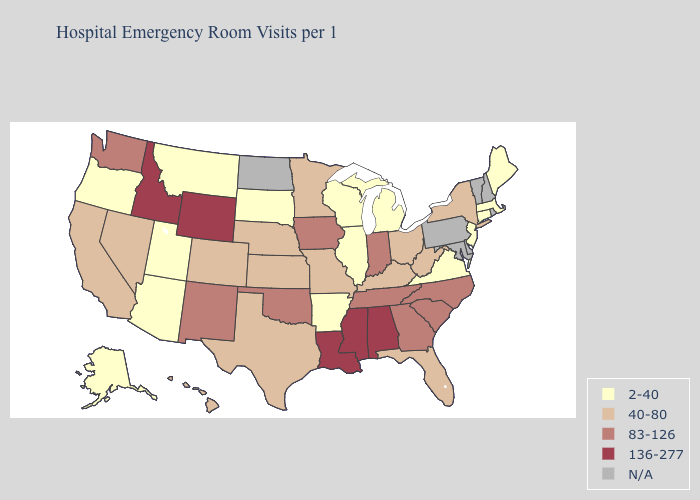Among the states that border Ohio , does Kentucky have the lowest value?
Write a very short answer. No. Among the states that border West Virginia , does Virginia have the highest value?
Short answer required. No. What is the value of Alabama?
Give a very brief answer. 136-277. Name the states that have a value in the range 83-126?
Concise answer only. Georgia, Indiana, Iowa, New Mexico, North Carolina, Oklahoma, South Carolina, Tennessee, Washington. What is the value of South Carolina?
Short answer required. 83-126. How many symbols are there in the legend?
Be succinct. 5. What is the value of Arkansas?
Keep it brief. 2-40. Name the states that have a value in the range 40-80?
Short answer required. California, Colorado, Florida, Hawaii, Kansas, Kentucky, Minnesota, Missouri, Nebraska, Nevada, New York, Ohio, Texas, West Virginia. What is the value of Idaho?
Quick response, please. 136-277. What is the value of Virginia?
Quick response, please. 2-40. Does the first symbol in the legend represent the smallest category?
Be succinct. Yes. Which states have the lowest value in the Northeast?
Concise answer only. Connecticut, Maine, Massachusetts, New Jersey. Which states hav the highest value in the West?
Quick response, please. Idaho, Wyoming. What is the value of Montana?
Quick response, please. 2-40. 